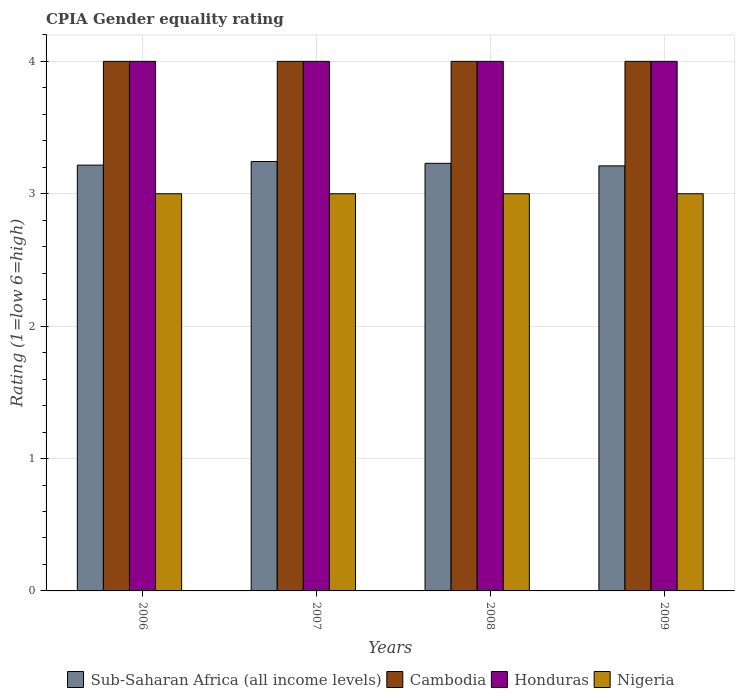How many different coloured bars are there?
Your answer should be compact. 4. Are the number of bars per tick equal to the number of legend labels?
Your response must be concise. Yes. Are the number of bars on each tick of the X-axis equal?
Make the answer very short. Yes. What is the CPIA rating in Honduras in 2006?
Offer a very short reply. 4. Across all years, what is the maximum CPIA rating in Nigeria?
Offer a terse response. 3. Across all years, what is the minimum CPIA rating in Sub-Saharan Africa (all income levels)?
Ensure brevity in your answer.  3.21. What is the total CPIA rating in Nigeria in the graph?
Your response must be concise. 12. What is the difference between the CPIA rating in Cambodia in 2006 and that in 2009?
Your answer should be compact. 0. What is the difference between the CPIA rating in Cambodia in 2007 and the CPIA rating in Sub-Saharan Africa (all income levels) in 2008?
Make the answer very short. 0.77. What is the average CPIA rating in Cambodia per year?
Ensure brevity in your answer.  4. In the year 2007, what is the difference between the CPIA rating in Sub-Saharan Africa (all income levels) and CPIA rating in Cambodia?
Ensure brevity in your answer.  -0.76. What is the ratio of the CPIA rating in Cambodia in 2007 to that in 2008?
Ensure brevity in your answer.  1. Is the CPIA rating in Nigeria in 2007 less than that in 2008?
Ensure brevity in your answer.  No. What is the difference between the highest and the lowest CPIA rating in Sub-Saharan Africa (all income levels)?
Offer a terse response. 0.03. Is the sum of the CPIA rating in Cambodia in 2007 and 2008 greater than the maximum CPIA rating in Sub-Saharan Africa (all income levels) across all years?
Provide a succinct answer. Yes. Is it the case that in every year, the sum of the CPIA rating in Nigeria and CPIA rating in Sub-Saharan Africa (all income levels) is greater than the sum of CPIA rating in Honduras and CPIA rating in Cambodia?
Offer a very short reply. No. What does the 1st bar from the left in 2008 represents?
Make the answer very short. Sub-Saharan Africa (all income levels). What does the 3rd bar from the right in 2007 represents?
Keep it short and to the point. Cambodia. Does the graph contain grids?
Your answer should be very brief. Yes. What is the title of the graph?
Your answer should be very brief. CPIA Gender equality rating. Does "Mexico" appear as one of the legend labels in the graph?
Your answer should be very brief. No. What is the label or title of the Y-axis?
Ensure brevity in your answer.  Rating (1=low 6=high). What is the Rating (1=low 6=high) in Sub-Saharan Africa (all income levels) in 2006?
Offer a very short reply. 3.22. What is the Rating (1=low 6=high) in Cambodia in 2006?
Ensure brevity in your answer.  4. What is the Rating (1=low 6=high) in Honduras in 2006?
Ensure brevity in your answer.  4. What is the Rating (1=low 6=high) of Sub-Saharan Africa (all income levels) in 2007?
Offer a terse response. 3.24. What is the Rating (1=low 6=high) in Honduras in 2007?
Make the answer very short. 4. What is the Rating (1=low 6=high) of Nigeria in 2007?
Ensure brevity in your answer.  3. What is the Rating (1=low 6=high) of Sub-Saharan Africa (all income levels) in 2008?
Keep it short and to the point. 3.23. What is the Rating (1=low 6=high) in Cambodia in 2008?
Your response must be concise. 4. What is the Rating (1=low 6=high) in Honduras in 2008?
Provide a short and direct response. 4. What is the Rating (1=low 6=high) of Nigeria in 2008?
Ensure brevity in your answer.  3. What is the Rating (1=low 6=high) in Sub-Saharan Africa (all income levels) in 2009?
Your response must be concise. 3.21. What is the Rating (1=low 6=high) in Honduras in 2009?
Make the answer very short. 4. Across all years, what is the maximum Rating (1=low 6=high) in Sub-Saharan Africa (all income levels)?
Your response must be concise. 3.24. Across all years, what is the maximum Rating (1=low 6=high) in Cambodia?
Offer a terse response. 4. Across all years, what is the maximum Rating (1=low 6=high) in Honduras?
Offer a terse response. 4. Across all years, what is the maximum Rating (1=low 6=high) in Nigeria?
Keep it short and to the point. 3. Across all years, what is the minimum Rating (1=low 6=high) of Sub-Saharan Africa (all income levels)?
Provide a succinct answer. 3.21. Across all years, what is the minimum Rating (1=low 6=high) in Cambodia?
Offer a terse response. 4. What is the total Rating (1=low 6=high) of Sub-Saharan Africa (all income levels) in the graph?
Make the answer very short. 12.9. What is the total Rating (1=low 6=high) in Honduras in the graph?
Keep it short and to the point. 16. What is the difference between the Rating (1=low 6=high) of Sub-Saharan Africa (all income levels) in 2006 and that in 2007?
Make the answer very short. -0.03. What is the difference between the Rating (1=low 6=high) in Honduras in 2006 and that in 2007?
Provide a short and direct response. 0. What is the difference between the Rating (1=low 6=high) of Sub-Saharan Africa (all income levels) in 2006 and that in 2008?
Your answer should be very brief. -0.01. What is the difference between the Rating (1=low 6=high) of Cambodia in 2006 and that in 2008?
Your answer should be very brief. 0. What is the difference between the Rating (1=low 6=high) of Sub-Saharan Africa (all income levels) in 2006 and that in 2009?
Ensure brevity in your answer.  0.01. What is the difference between the Rating (1=low 6=high) of Honduras in 2006 and that in 2009?
Your answer should be very brief. 0. What is the difference between the Rating (1=low 6=high) of Nigeria in 2006 and that in 2009?
Keep it short and to the point. 0. What is the difference between the Rating (1=low 6=high) in Sub-Saharan Africa (all income levels) in 2007 and that in 2008?
Make the answer very short. 0.01. What is the difference between the Rating (1=low 6=high) of Sub-Saharan Africa (all income levels) in 2007 and that in 2009?
Provide a succinct answer. 0.03. What is the difference between the Rating (1=low 6=high) in Sub-Saharan Africa (all income levels) in 2008 and that in 2009?
Give a very brief answer. 0.02. What is the difference between the Rating (1=low 6=high) of Cambodia in 2008 and that in 2009?
Provide a succinct answer. 0. What is the difference between the Rating (1=low 6=high) of Honduras in 2008 and that in 2009?
Your answer should be very brief. 0. What is the difference between the Rating (1=low 6=high) in Nigeria in 2008 and that in 2009?
Provide a succinct answer. 0. What is the difference between the Rating (1=low 6=high) of Sub-Saharan Africa (all income levels) in 2006 and the Rating (1=low 6=high) of Cambodia in 2007?
Give a very brief answer. -0.78. What is the difference between the Rating (1=low 6=high) in Sub-Saharan Africa (all income levels) in 2006 and the Rating (1=low 6=high) in Honduras in 2007?
Your answer should be compact. -0.78. What is the difference between the Rating (1=low 6=high) in Sub-Saharan Africa (all income levels) in 2006 and the Rating (1=low 6=high) in Nigeria in 2007?
Ensure brevity in your answer.  0.22. What is the difference between the Rating (1=low 6=high) in Sub-Saharan Africa (all income levels) in 2006 and the Rating (1=low 6=high) in Cambodia in 2008?
Ensure brevity in your answer.  -0.78. What is the difference between the Rating (1=low 6=high) in Sub-Saharan Africa (all income levels) in 2006 and the Rating (1=low 6=high) in Honduras in 2008?
Provide a short and direct response. -0.78. What is the difference between the Rating (1=low 6=high) of Sub-Saharan Africa (all income levels) in 2006 and the Rating (1=low 6=high) of Nigeria in 2008?
Offer a very short reply. 0.22. What is the difference between the Rating (1=low 6=high) of Cambodia in 2006 and the Rating (1=low 6=high) of Nigeria in 2008?
Offer a terse response. 1. What is the difference between the Rating (1=low 6=high) in Sub-Saharan Africa (all income levels) in 2006 and the Rating (1=low 6=high) in Cambodia in 2009?
Provide a succinct answer. -0.78. What is the difference between the Rating (1=low 6=high) of Sub-Saharan Africa (all income levels) in 2006 and the Rating (1=low 6=high) of Honduras in 2009?
Make the answer very short. -0.78. What is the difference between the Rating (1=low 6=high) of Sub-Saharan Africa (all income levels) in 2006 and the Rating (1=low 6=high) of Nigeria in 2009?
Give a very brief answer. 0.22. What is the difference between the Rating (1=low 6=high) of Cambodia in 2006 and the Rating (1=low 6=high) of Nigeria in 2009?
Provide a succinct answer. 1. What is the difference between the Rating (1=low 6=high) in Sub-Saharan Africa (all income levels) in 2007 and the Rating (1=low 6=high) in Cambodia in 2008?
Your answer should be compact. -0.76. What is the difference between the Rating (1=low 6=high) in Sub-Saharan Africa (all income levels) in 2007 and the Rating (1=low 6=high) in Honduras in 2008?
Ensure brevity in your answer.  -0.76. What is the difference between the Rating (1=low 6=high) in Sub-Saharan Africa (all income levels) in 2007 and the Rating (1=low 6=high) in Nigeria in 2008?
Provide a short and direct response. 0.24. What is the difference between the Rating (1=low 6=high) of Cambodia in 2007 and the Rating (1=low 6=high) of Honduras in 2008?
Offer a very short reply. 0. What is the difference between the Rating (1=low 6=high) in Honduras in 2007 and the Rating (1=low 6=high) in Nigeria in 2008?
Your answer should be compact. 1. What is the difference between the Rating (1=low 6=high) in Sub-Saharan Africa (all income levels) in 2007 and the Rating (1=low 6=high) in Cambodia in 2009?
Give a very brief answer. -0.76. What is the difference between the Rating (1=low 6=high) in Sub-Saharan Africa (all income levels) in 2007 and the Rating (1=low 6=high) in Honduras in 2009?
Make the answer very short. -0.76. What is the difference between the Rating (1=low 6=high) of Sub-Saharan Africa (all income levels) in 2007 and the Rating (1=low 6=high) of Nigeria in 2009?
Ensure brevity in your answer.  0.24. What is the difference between the Rating (1=low 6=high) of Sub-Saharan Africa (all income levels) in 2008 and the Rating (1=low 6=high) of Cambodia in 2009?
Ensure brevity in your answer.  -0.77. What is the difference between the Rating (1=low 6=high) in Sub-Saharan Africa (all income levels) in 2008 and the Rating (1=low 6=high) in Honduras in 2009?
Give a very brief answer. -0.77. What is the difference between the Rating (1=low 6=high) of Sub-Saharan Africa (all income levels) in 2008 and the Rating (1=low 6=high) of Nigeria in 2009?
Give a very brief answer. 0.23. What is the difference between the Rating (1=low 6=high) of Cambodia in 2008 and the Rating (1=low 6=high) of Honduras in 2009?
Your response must be concise. 0. What is the difference between the Rating (1=low 6=high) of Cambodia in 2008 and the Rating (1=low 6=high) of Nigeria in 2009?
Offer a terse response. 1. What is the average Rating (1=low 6=high) in Sub-Saharan Africa (all income levels) per year?
Your response must be concise. 3.22. What is the average Rating (1=low 6=high) of Honduras per year?
Keep it short and to the point. 4. In the year 2006, what is the difference between the Rating (1=low 6=high) in Sub-Saharan Africa (all income levels) and Rating (1=low 6=high) in Cambodia?
Your response must be concise. -0.78. In the year 2006, what is the difference between the Rating (1=low 6=high) in Sub-Saharan Africa (all income levels) and Rating (1=low 6=high) in Honduras?
Ensure brevity in your answer.  -0.78. In the year 2006, what is the difference between the Rating (1=low 6=high) in Sub-Saharan Africa (all income levels) and Rating (1=low 6=high) in Nigeria?
Provide a succinct answer. 0.22. In the year 2006, what is the difference between the Rating (1=low 6=high) of Cambodia and Rating (1=low 6=high) of Honduras?
Your answer should be very brief. 0. In the year 2006, what is the difference between the Rating (1=low 6=high) of Honduras and Rating (1=low 6=high) of Nigeria?
Give a very brief answer. 1. In the year 2007, what is the difference between the Rating (1=low 6=high) in Sub-Saharan Africa (all income levels) and Rating (1=low 6=high) in Cambodia?
Offer a very short reply. -0.76. In the year 2007, what is the difference between the Rating (1=low 6=high) of Sub-Saharan Africa (all income levels) and Rating (1=low 6=high) of Honduras?
Provide a short and direct response. -0.76. In the year 2007, what is the difference between the Rating (1=low 6=high) in Sub-Saharan Africa (all income levels) and Rating (1=low 6=high) in Nigeria?
Provide a succinct answer. 0.24. In the year 2008, what is the difference between the Rating (1=low 6=high) of Sub-Saharan Africa (all income levels) and Rating (1=low 6=high) of Cambodia?
Your answer should be very brief. -0.77. In the year 2008, what is the difference between the Rating (1=low 6=high) in Sub-Saharan Africa (all income levels) and Rating (1=low 6=high) in Honduras?
Your answer should be compact. -0.77. In the year 2008, what is the difference between the Rating (1=low 6=high) of Sub-Saharan Africa (all income levels) and Rating (1=low 6=high) of Nigeria?
Your response must be concise. 0.23. In the year 2008, what is the difference between the Rating (1=low 6=high) of Cambodia and Rating (1=low 6=high) of Honduras?
Your response must be concise. 0. In the year 2008, what is the difference between the Rating (1=low 6=high) of Cambodia and Rating (1=low 6=high) of Nigeria?
Give a very brief answer. 1. In the year 2008, what is the difference between the Rating (1=low 6=high) in Honduras and Rating (1=low 6=high) in Nigeria?
Provide a succinct answer. 1. In the year 2009, what is the difference between the Rating (1=low 6=high) of Sub-Saharan Africa (all income levels) and Rating (1=low 6=high) of Cambodia?
Give a very brief answer. -0.79. In the year 2009, what is the difference between the Rating (1=low 6=high) in Sub-Saharan Africa (all income levels) and Rating (1=low 6=high) in Honduras?
Provide a succinct answer. -0.79. In the year 2009, what is the difference between the Rating (1=low 6=high) of Sub-Saharan Africa (all income levels) and Rating (1=low 6=high) of Nigeria?
Offer a very short reply. 0.21. In the year 2009, what is the difference between the Rating (1=low 6=high) of Cambodia and Rating (1=low 6=high) of Nigeria?
Your answer should be compact. 1. What is the ratio of the Rating (1=low 6=high) of Sub-Saharan Africa (all income levels) in 2006 to that in 2007?
Keep it short and to the point. 0.99. What is the ratio of the Rating (1=low 6=high) of Honduras in 2006 to that in 2007?
Your response must be concise. 1. What is the ratio of the Rating (1=low 6=high) in Sub-Saharan Africa (all income levels) in 2006 to that in 2008?
Give a very brief answer. 1. What is the ratio of the Rating (1=low 6=high) in Cambodia in 2006 to that in 2008?
Offer a very short reply. 1. What is the ratio of the Rating (1=low 6=high) in Honduras in 2006 to that in 2008?
Keep it short and to the point. 1. What is the ratio of the Rating (1=low 6=high) in Nigeria in 2006 to that in 2008?
Give a very brief answer. 1. What is the ratio of the Rating (1=low 6=high) in Sub-Saharan Africa (all income levels) in 2006 to that in 2009?
Keep it short and to the point. 1. What is the ratio of the Rating (1=low 6=high) of Cambodia in 2006 to that in 2009?
Your answer should be compact. 1. What is the ratio of the Rating (1=low 6=high) of Honduras in 2006 to that in 2009?
Provide a short and direct response. 1. What is the ratio of the Rating (1=low 6=high) of Nigeria in 2007 to that in 2008?
Make the answer very short. 1. What is the ratio of the Rating (1=low 6=high) of Sub-Saharan Africa (all income levels) in 2007 to that in 2009?
Ensure brevity in your answer.  1.01. What is the ratio of the Rating (1=low 6=high) in Honduras in 2007 to that in 2009?
Give a very brief answer. 1. What is the ratio of the Rating (1=low 6=high) in Honduras in 2008 to that in 2009?
Provide a short and direct response. 1. What is the difference between the highest and the second highest Rating (1=low 6=high) of Sub-Saharan Africa (all income levels)?
Make the answer very short. 0.01. What is the difference between the highest and the lowest Rating (1=low 6=high) in Sub-Saharan Africa (all income levels)?
Keep it short and to the point. 0.03. What is the difference between the highest and the lowest Rating (1=low 6=high) of Honduras?
Provide a succinct answer. 0. 